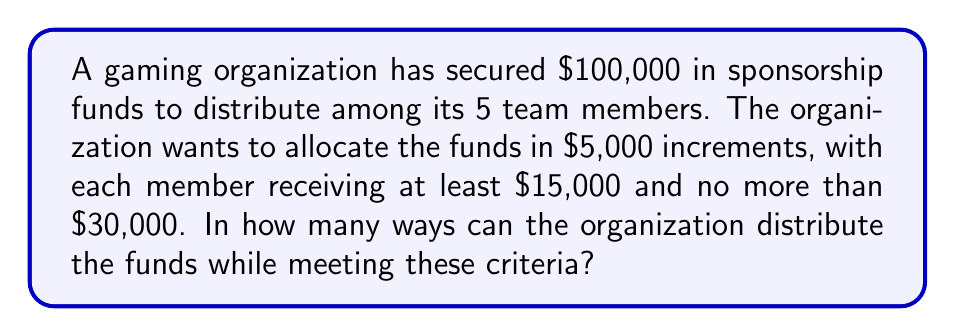Give your solution to this math problem. Let's approach this step-by-step using the stars and bars method:

1) First, we need to calculate how many $5,000 increments we're distributing:
   $100,000 ÷ $5,000 = 20$ increments

2) Each player must receive at least $15,000, which is 3 increments. So we can start by giving each player 3 increments:
   $5 \times 3 = 15$ increments are now fixed

3) We now have $20 - 15 = 5$ increments left to distribute

4) The maximum any player can receive is $30,000, which is 6 increments. Since they already have 3, they can receive at most 3 more.

5) This problem is now equivalent to distributing 5 identical objects (the remaining increments) into 5 distinct boxes (the players), where each box can hold 0 to 3 objects.

6) This is a classic stars and bars problem with restrictions. We can solve it using the principle of inclusion-exclusion.

7) Let $N(r)$ be the number of ways to distribute the increments if $r$ players receive more than 3 additional increments.

   $N(0) = \binom{5+5-1}{5-1} = \binom{9}{4} = 126$

   $N(1) = \binom{5}{1}\binom{5+5-4-1}{5-1} = 5 \times \binom{5}{4} = 25$

   $N(2) = \binom{5}{2}\binom{5+5-7-1}{5-1} = 10 \times \binom{2}{4} = 0$

8) The final answer is:

   $N(0) - N(1) + N(2) = 126 - 25 + 0 = 101$

Therefore, there are 101 ways to distribute the funds.
Answer: 101 